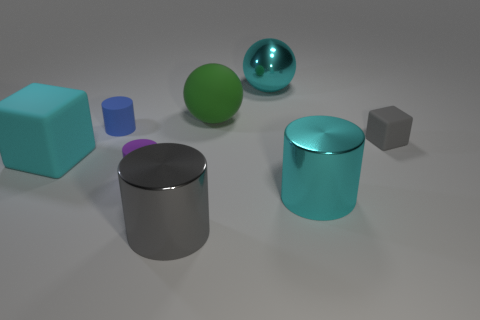Is there a blue matte cylinder?
Make the answer very short. Yes. Is the cyan rubber thing the same shape as the small gray thing?
Provide a short and direct response. Yes. What number of large green balls are on the right side of the gray cylinder in front of the large cyan shiny thing that is to the right of the large cyan metal ball?
Provide a short and direct response. 1. What is the material of the big cyan thing that is both behind the tiny purple object and in front of the blue cylinder?
Your response must be concise. Rubber. The small object that is both behind the purple matte cylinder and on the left side of the large green rubber ball is what color?
Give a very brief answer. Blue. Are there any other things that have the same color as the large matte block?
Your response must be concise. Yes. What is the shape of the metal thing that is on the left side of the large cyan object behind the cylinder behind the gray rubber object?
Your answer should be compact. Cylinder. What is the color of the other shiny thing that is the same shape as the large green thing?
Your response must be concise. Cyan. What color is the ball that is in front of the big shiny object that is behind the purple matte thing?
Give a very brief answer. Green. There is a cyan shiny thing that is the same shape as the big gray object; what is its size?
Provide a short and direct response. Large. 